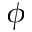<formula> <loc_0><loc_0><loc_500><loc_500>\phi</formula> 